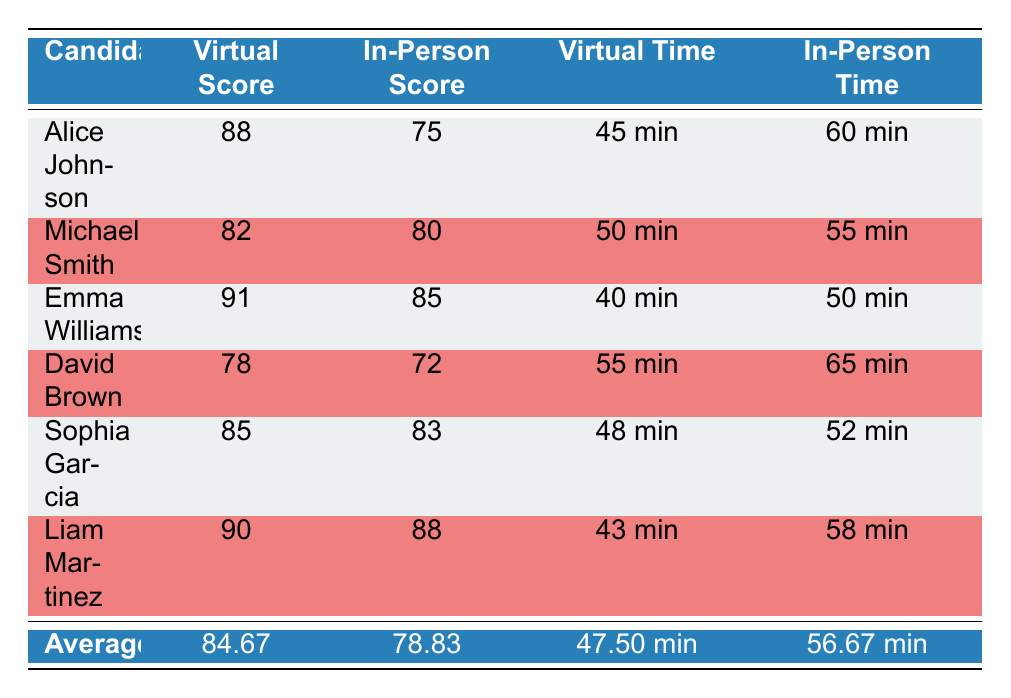What is the virtual interview score of Alice Johnson? The table clearly states Alice Johnson's virtual interview score as 88.
Answer: 88 What is the average in-person interview score? To calculate the average in-person score, add the individual scores (75 + 80 + 85 + 72 + 83 + 88 = 483) and divide by the total number of candidates (6), which results in 483/6 = 80.5. The table indicates the average is 78.83, which must be confirmed directly from the data presented in the table.
Answer: 78.83 Did David Brown score higher in the virtual interview compared to his in-person interview? David Brown's virtual score is 78 and in-person score is 72. Since 78 is greater than 72, the statement is true.
Answer: Yes Who had the highest virtual interview score? According to the table, Emma Williams has the highest virtual interview score of 91, as noted in the highest virtual score section.
Answer: Emma Williams What is the difference in scores between Liam Martinez's virtual and in-person interview outcomes? Liam scored 90 in the virtual interview and 88 in the in-person interview. The difference is calculated as 90 - 88 = 2.
Answer: 2 Is the average virtual assessment completion time less than the average in-person assessment completion time? The average virtual assessment time is 47.50 minutes and the average in-person time is 56.67 minutes. Since 47.50 is less than 56.67, the statement is true.
Answer: Yes Which candidate completed their virtual assessment the fastest, and what was the time? The table shows that Emma Williams completed her virtual assessment in 40 minutes, which is the shortest time among all candidates listed.
Answer: Emma Williams, 40 minutes If we consider both types of interview scores, who had the highest overall score? To determine who had the highest overall score, we compare these totals: Alice Johnson (88 + 75 = 163), Michael Smith (82 + 80 = 162), Emma Williams (91 + 85 = 176), David Brown (78 + 72 = 150), Sophia Garcia (85 + 83 = 168), and Liam Martinez (90 + 88 = 178). Comparing these sums, Liam Martinez has the highest overall score of 178.
Answer: Liam Martinez What was the virtual completion time of Sophia Garcia? Sophia Garcia's virtual assessment completion time is shown in the table as 48 minutes.
Answer: 48 minutes 